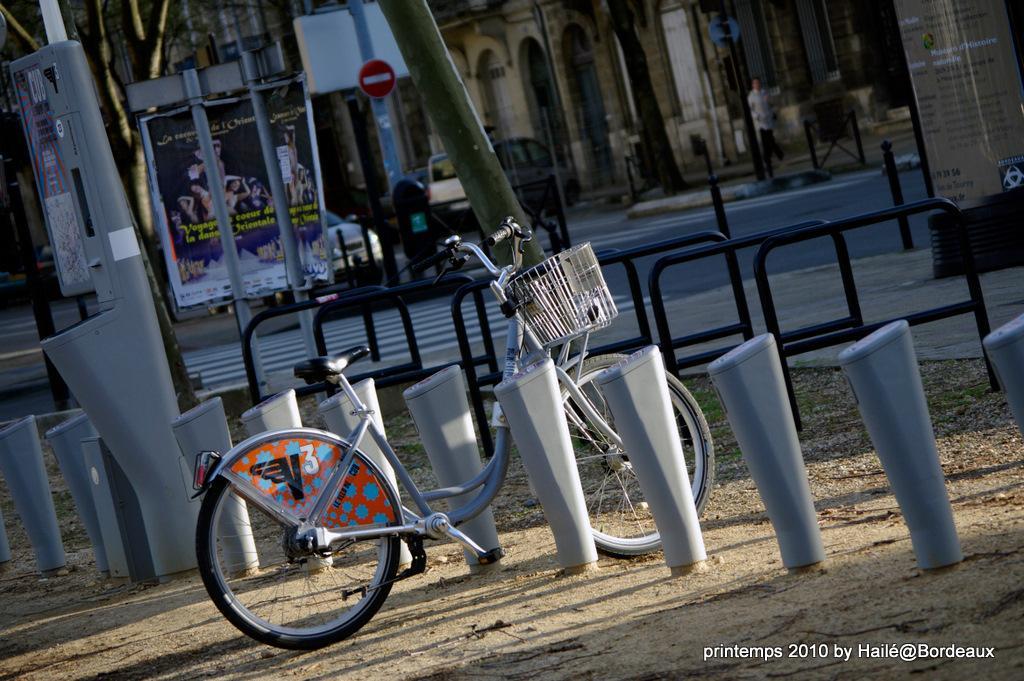Can you describe this image briefly? In the bottom right, there is a watermark. In the background, there are poles, there is a road on which, there are zebra crossings, there is a poster, there is a sign board, there is a vehicle and there are buildings. 